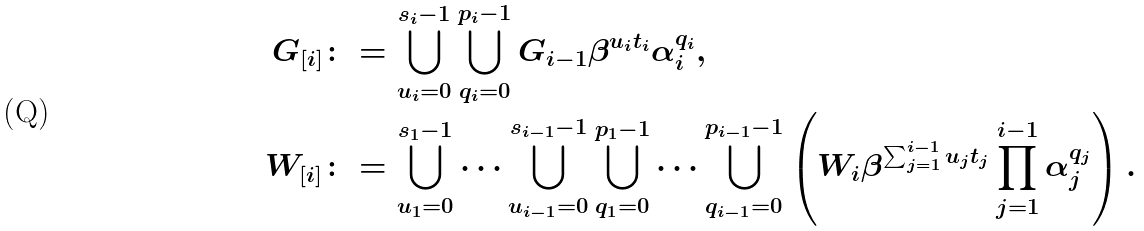<formula> <loc_0><loc_0><loc_500><loc_500>G _ { [ i ] } & \colon = \bigcup _ { u _ { i } = 0 } ^ { s _ { i } - 1 } \bigcup _ { q _ { i } = 0 } ^ { p _ { i } - 1 } G _ { i - 1 } \beta ^ { u _ { i } t _ { i } } \alpha _ { i } ^ { q _ { i } } , \\ W _ { [ i ] } & \colon = \bigcup _ { u _ { 1 } = 0 } ^ { s _ { 1 } - 1 } \dots \bigcup _ { u _ { i - 1 } = 0 } ^ { s _ { i - 1 } - 1 } \bigcup _ { q _ { 1 } = 0 } ^ { p _ { 1 } - 1 } \dots \bigcup _ { q _ { i - 1 } = 0 } ^ { p _ { i - 1 } - 1 } \left ( W _ { i } \beta ^ { \sum _ { j = 1 } ^ { i - 1 } u _ { j } t _ { j } } \prod _ { j = 1 } ^ { i - 1 } \alpha _ { j } ^ { q _ { j } } \right ) .</formula> 